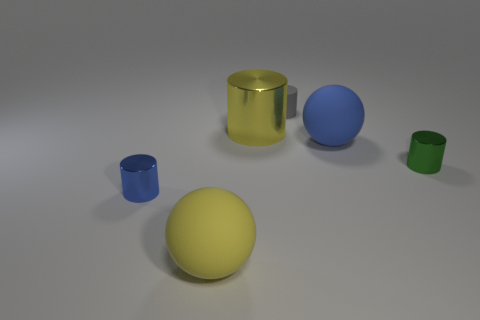Subtract all tiny rubber cylinders. How many cylinders are left? 3 Add 2 tiny objects. How many objects exist? 8 Subtract all cyan cylinders. Subtract all red spheres. How many cylinders are left? 4 Subtract all cylinders. How many objects are left? 2 Subtract 0 purple blocks. How many objects are left? 6 Subtract all yellow cylinders. Subtract all large metal things. How many objects are left? 4 Add 5 tiny gray matte cylinders. How many tiny gray matte cylinders are left? 6 Add 3 metallic cylinders. How many metallic cylinders exist? 6 